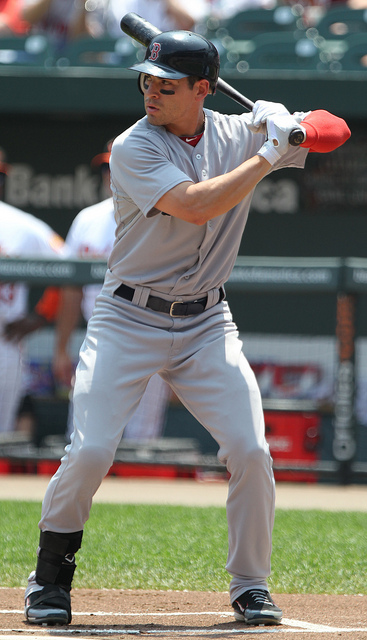<image>What letter is on his helmet? I am not sure what letter is on his helmet. It could be 'b' or 's'. What letter is on his helmet? I don't know what letter is on his helmet. It can be 'b' or 's'. 